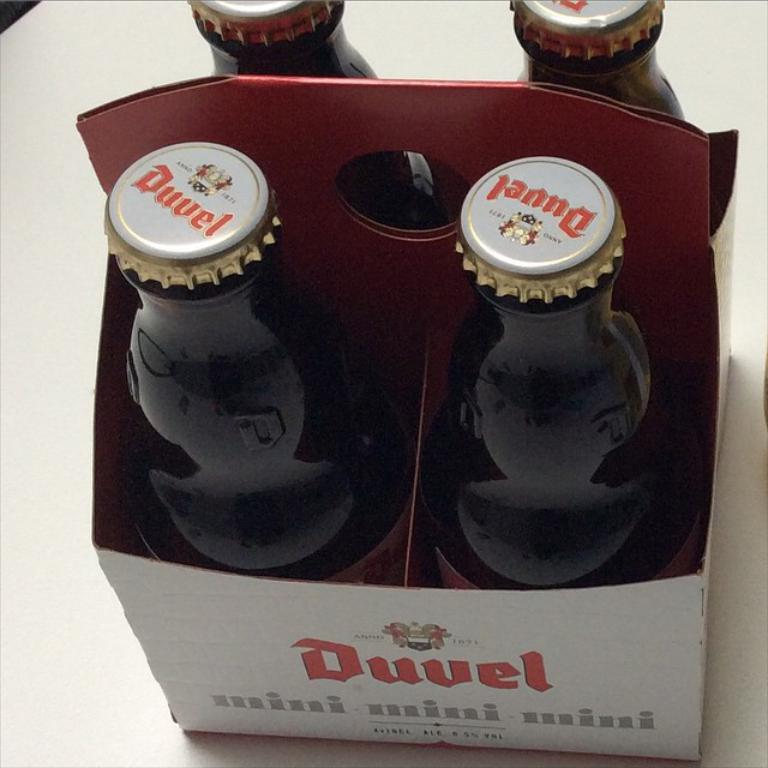<image>
Describe the image concisely. a close up of a four pack of Duvel drink 